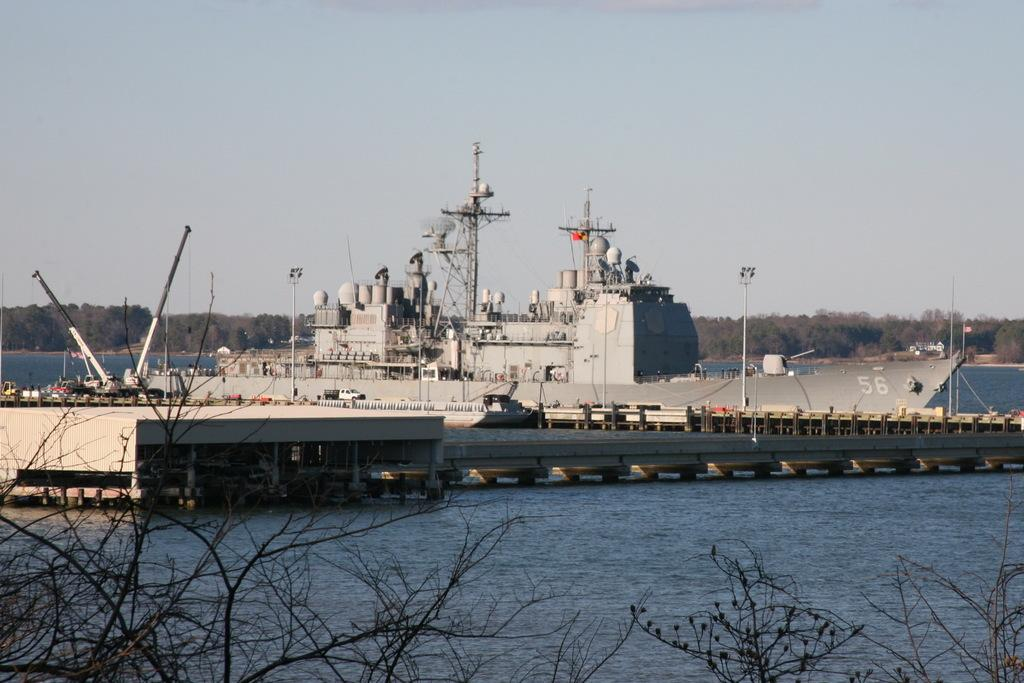What is the main subject of the image? The main subject of the image is a ship. Where is the ship located in the image? The ship is on the water. What structures can be seen on the ship? There is a tower and light poles on the ship. What else is visible in the image besides the ship? There is a bridge, dried trees, trees in the background, and the sky visible in the background. How many snakes are slithering on the ship in the image? There are no snakes visible in the image; the ship has a tower and light poles instead. Can you describe the men on the ship in the image? There are no men present in the image; it only features a ship, a tower, light poles, a bridge, dried trees, trees in the background, and the sky. 